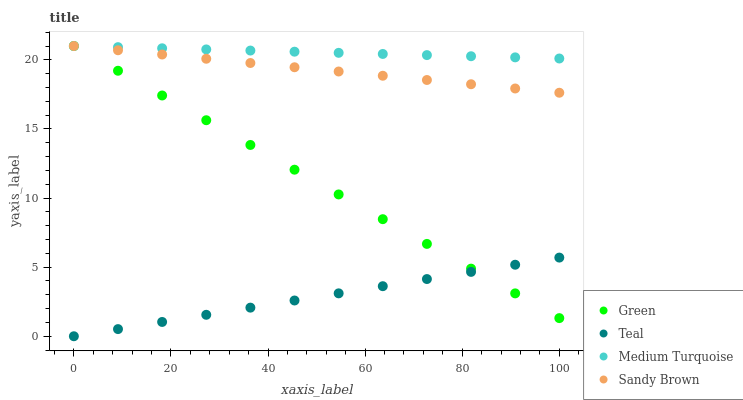Does Teal have the minimum area under the curve?
Answer yes or no. Yes. Does Medium Turquoise have the maximum area under the curve?
Answer yes or no. Yes. Does Green have the minimum area under the curve?
Answer yes or no. No. Does Green have the maximum area under the curve?
Answer yes or no. No. Is Teal the smoothest?
Answer yes or no. Yes. Is Medium Turquoise the roughest?
Answer yes or no. Yes. Is Green the smoothest?
Answer yes or no. No. Is Green the roughest?
Answer yes or no. No. Does Teal have the lowest value?
Answer yes or no. Yes. Does Green have the lowest value?
Answer yes or no. No. Does Medium Turquoise have the highest value?
Answer yes or no. Yes. Does Teal have the highest value?
Answer yes or no. No. Is Teal less than Medium Turquoise?
Answer yes or no. Yes. Is Sandy Brown greater than Teal?
Answer yes or no. Yes. Does Sandy Brown intersect Green?
Answer yes or no. Yes. Is Sandy Brown less than Green?
Answer yes or no. No. Is Sandy Brown greater than Green?
Answer yes or no. No. Does Teal intersect Medium Turquoise?
Answer yes or no. No. 